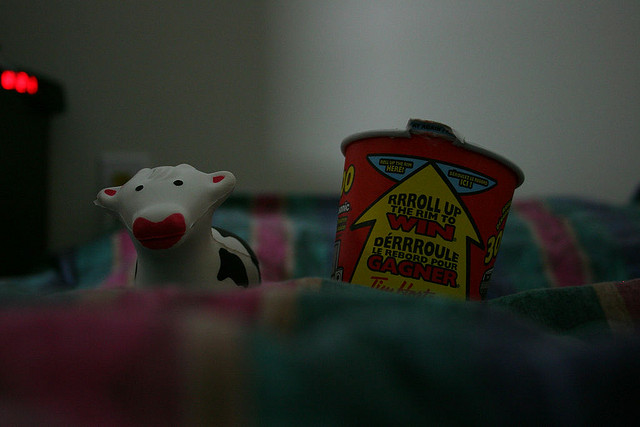Please transcribe the text in this image. RRROLL UP WIN DERRROULE GAGNER POUR REBORD LE Tiw 30 TO RIM THE CO 